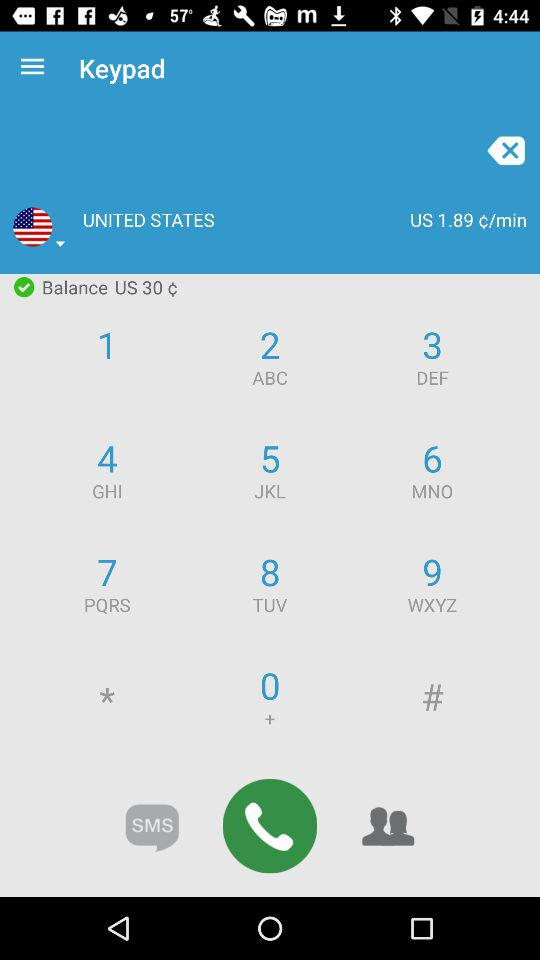How much is the balance in US dollars?
Answer the question using a single word or phrase. 30 $ 